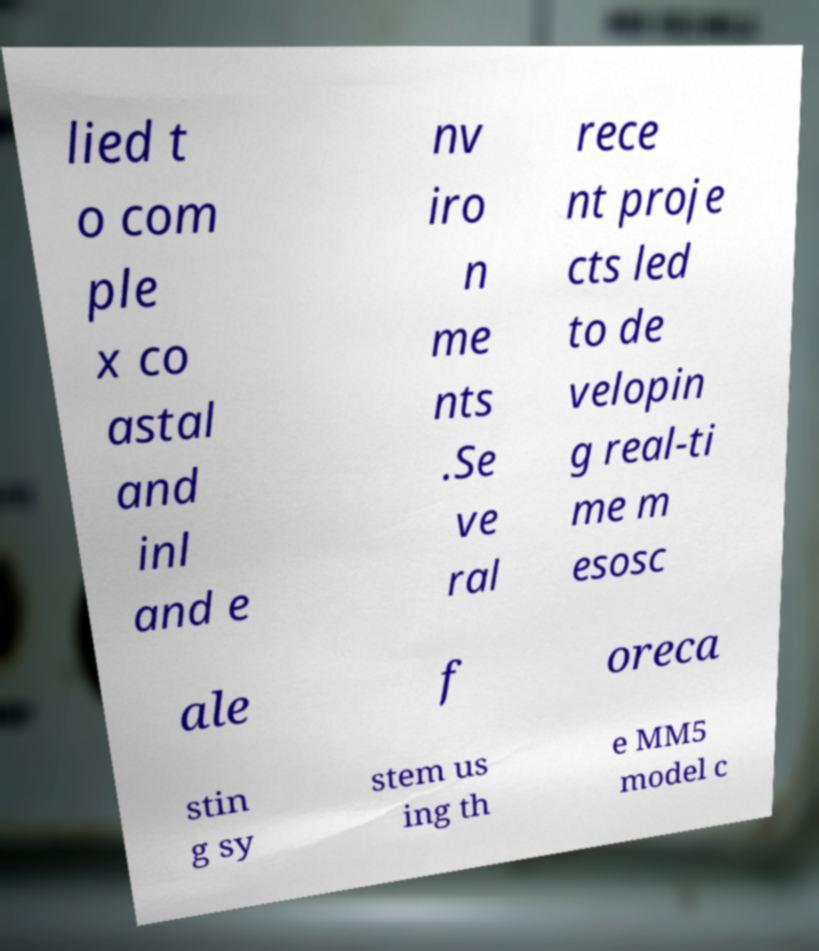I need the written content from this picture converted into text. Can you do that? lied t o com ple x co astal and inl and e nv iro n me nts .Se ve ral rece nt proje cts led to de velopin g real-ti me m esosc ale f oreca stin g sy stem us ing th e MM5 model c 